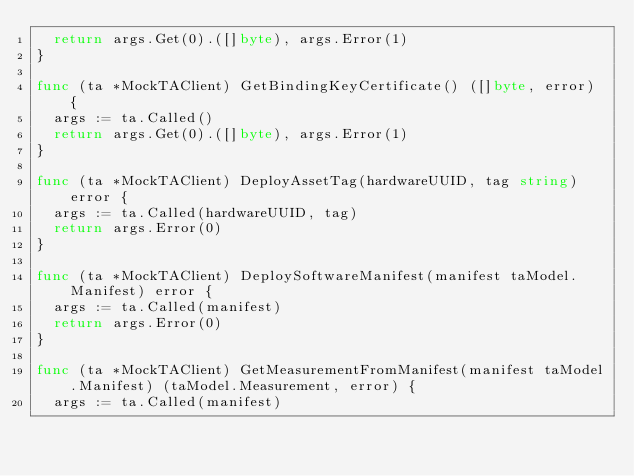Convert code to text. <code><loc_0><loc_0><loc_500><loc_500><_Go_>	return args.Get(0).([]byte), args.Error(1)
}

func (ta *MockTAClient) GetBindingKeyCertificate() ([]byte, error) {
	args := ta.Called()
	return args.Get(0).([]byte), args.Error(1)
}

func (ta *MockTAClient) DeployAssetTag(hardwareUUID, tag string) error {
	args := ta.Called(hardwareUUID, tag)
	return args.Error(0)
}

func (ta *MockTAClient) DeploySoftwareManifest(manifest taModel.Manifest) error {
	args := ta.Called(manifest)
	return args.Error(0)
}

func (ta *MockTAClient) GetMeasurementFromManifest(manifest taModel.Manifest) (taModel.Measurement, error) {
	args := ta.Called(manifest)</code> 